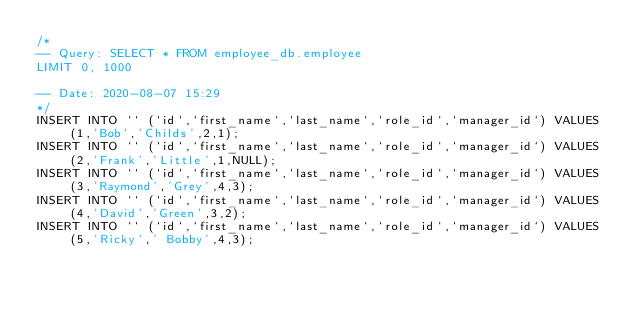<code> <loc_0><loc_0><loc_500><loc_500><_SQL_>/*
-- Query: SELECT * FROM employee_db.employee
LIMIT 0, 1000

-- Date: 2020-08-07 15:29
*/
INSERT INTO `` (`id`,`first_name`,`last_name`,`role_id`,`manager_id`) VALUES (1,'Bob','Childs',2,1);
INSERT INTO `` (`id`,`first_name`,`last_name`,`role_id`,`manager_id`) VALUES (2,'Frank','Little',1,NULL);
INSERT INTO `` (`id`,`first_name`,`last_name`,`role_id`,`manager_id`) VALUES (3,'Raymond','Grey',4,3);
INSERT INTO `` (`id`,`first_name`,`last_name`,`role_id`,`manager_id`) VALUES (4,'David','Green',3,2);
INSERT INTO `` (`id`,`first_name`,`last_name`,`role_id`,`manager_id`) VALUES (5,'Ricky',' Bobby',4,3);
</code> 